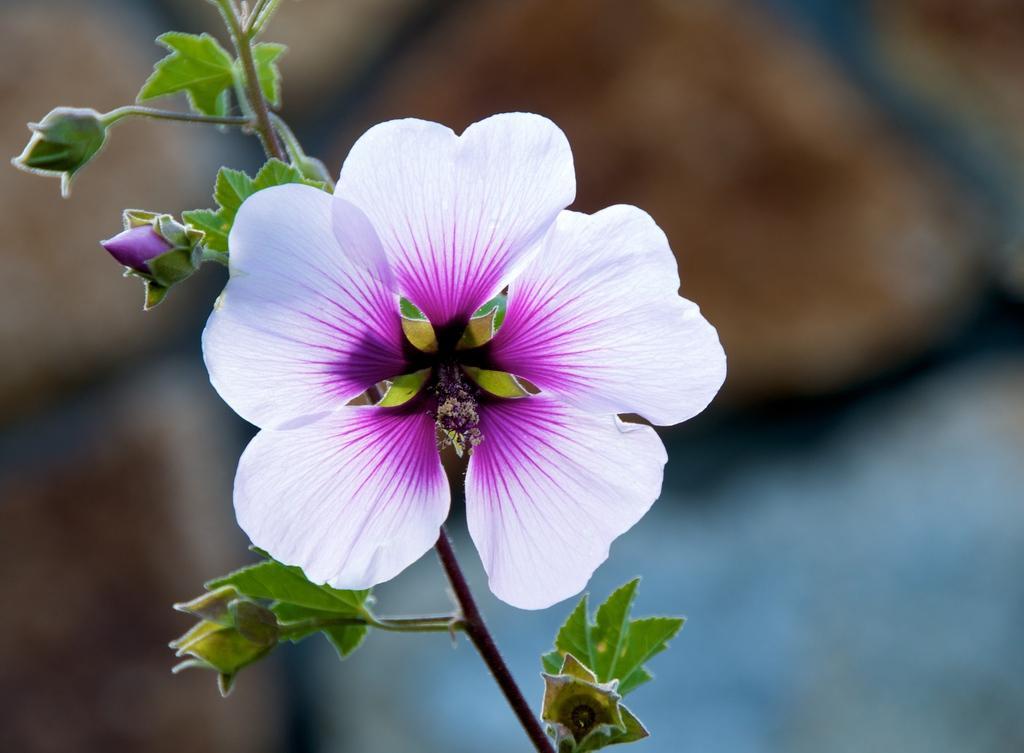Describe this image in one or two sentences. This is the picture of a plant where there is a flower with white and pink combination and with pink buds. 